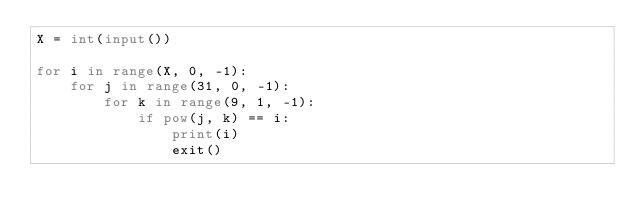Convert code to text. <code><loc_0><loc_0><loc_500><loc_500><_Python_>X = int(input())

for i in range(X, 0, -1):
    for j in range(31, 0, -1):
        for k in range(9, 1, -1):
            if pow(j, k) == i:
                print(i)
                exit()</code> 